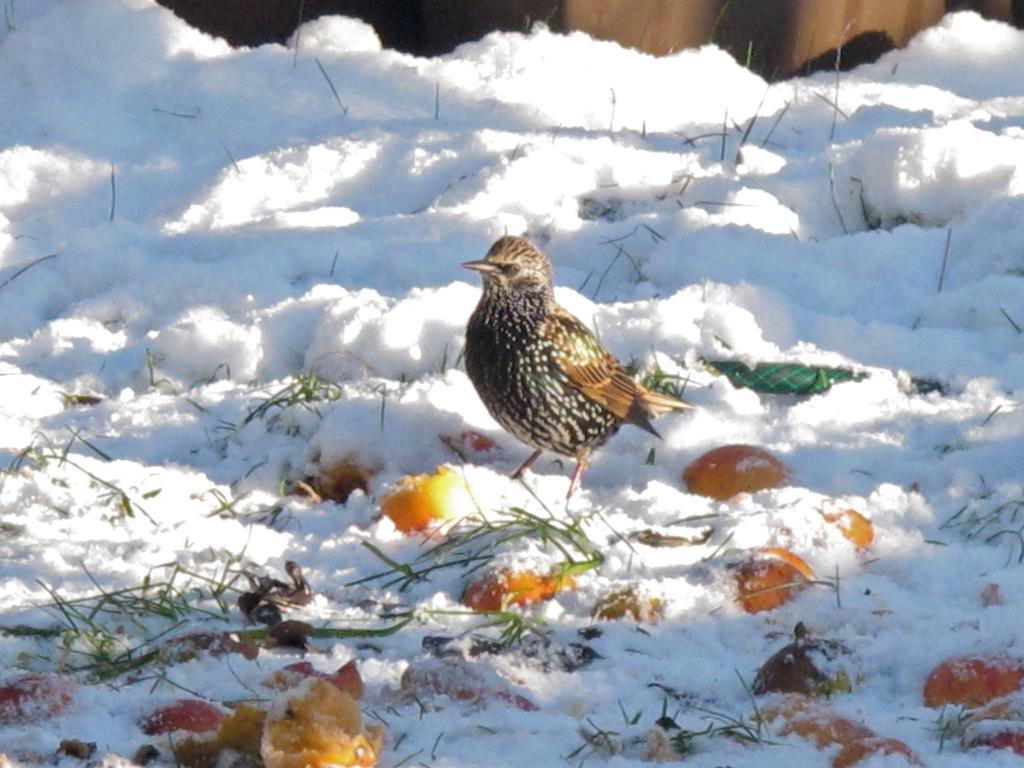What type of food items can be seen in the image? There are fruits in the image. What animal is present in the image? There is a bird in the image. What is the condition of the ground in the image? The ground is covered with snow in the image. What type of sponge is the bird using to clean its feathers in the image? There is no sponge present in the image, and the bird is not shown cleaning its feathers. 